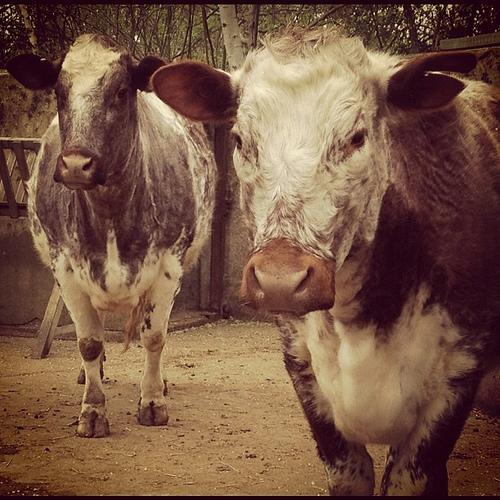Provide a brief description of the image, focusing on the primary animals and their surroundings. In the image, two cows stand on a farm amidst dirt, trees, and a fence, with one possibly being male and the other female. Mention the most prominent animals present in the image and their surroundings. Two cows are outside on a farm, standing in dirt with a fence and trees in the background. Write a concise summary of the scene depicted in the image. Two cows are standing next to each other outdoors on a farm with trees, dirt, and a fence around them. Identify the primary animals in the picture and describe their position in relation to each other. Two cows are standing next to each other outside during the day, with one slightly behind the other. What actions or emotions can be inferred from the image involving the main animals? Two cows appear to be looking at something, possibly wanting to be fed, while standing in dirt outside. In a few words, describe the main subjects of the image along with their environment. Cows on a dairy farm, surrounded by dirt, straw, trees, and a fence. Describe the facial features of the main animals in the image. The cows in the image have clearly visible eyes and a nose, with one cow displaying a more prominent nose. Briefly describe the main animals, their body parts visible in the image, and their environment. Two cows are shown with clearly visible eyes, nose, feet, and legs, standing on a farm with dirt, straw, and trees around them. Point out key features of the image, including the main animals, objects, and environment. Two cows are standing in an outdoor setting with a fence, trees, dirt, straw, and various body parts such as eyes, nose, and feet visible. What is the overall setting of the image, including the main animals and backdrop? The image depicts two cows on a dairy farm, standing in dirt with trees and a fence in the background. 